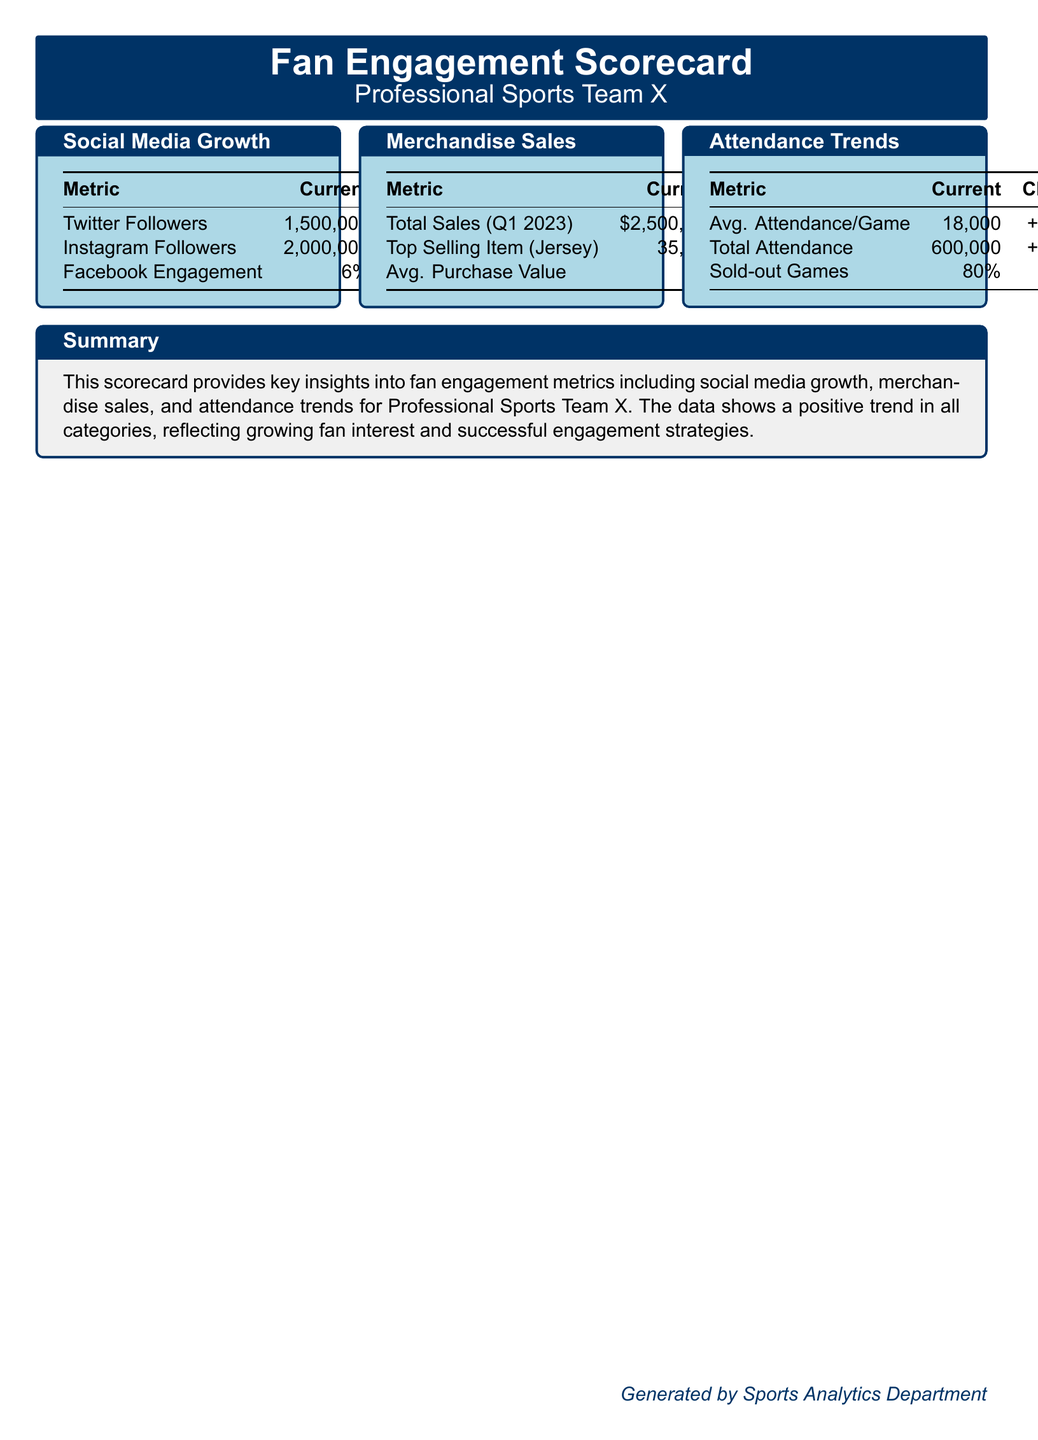What is the current number of Twitter followers? The document states that the current number of Twitter followers is 1,500,000.
Answer: 1,500,000 What is the change in Facebook engagement? According to the document, the change in Facebook engagement is +0.5%.
Answer: +0.5% What is the average purchase value of merchandise? The document indicates that the average purchase value is $75.
Answer: $75 What percentage of games were sold out? The scorecard shows that 80% of games were sold out.
Answer: 80% How much did total merchandise sales increase in Q1 2023? The increase in total merchandise sales is noted as +13.64% in the document.
Answer: +13.64% What is the total attendance recorded? The document lists the total attendance as 600,000.
Answer: 600,000 Which item is the top selling merchandise? The scorecard identifies the top selling item as a jersey.
Answer: Jersey What percentage increase did the average attendance per game experience? The average attendance per game increased by +2.86%.
Answer: +2.86% What does the summary indicate about fan engagement? The summary highlights positive trends in all categories, reflecting growing fan interest.
Answer: Growing fan interest 